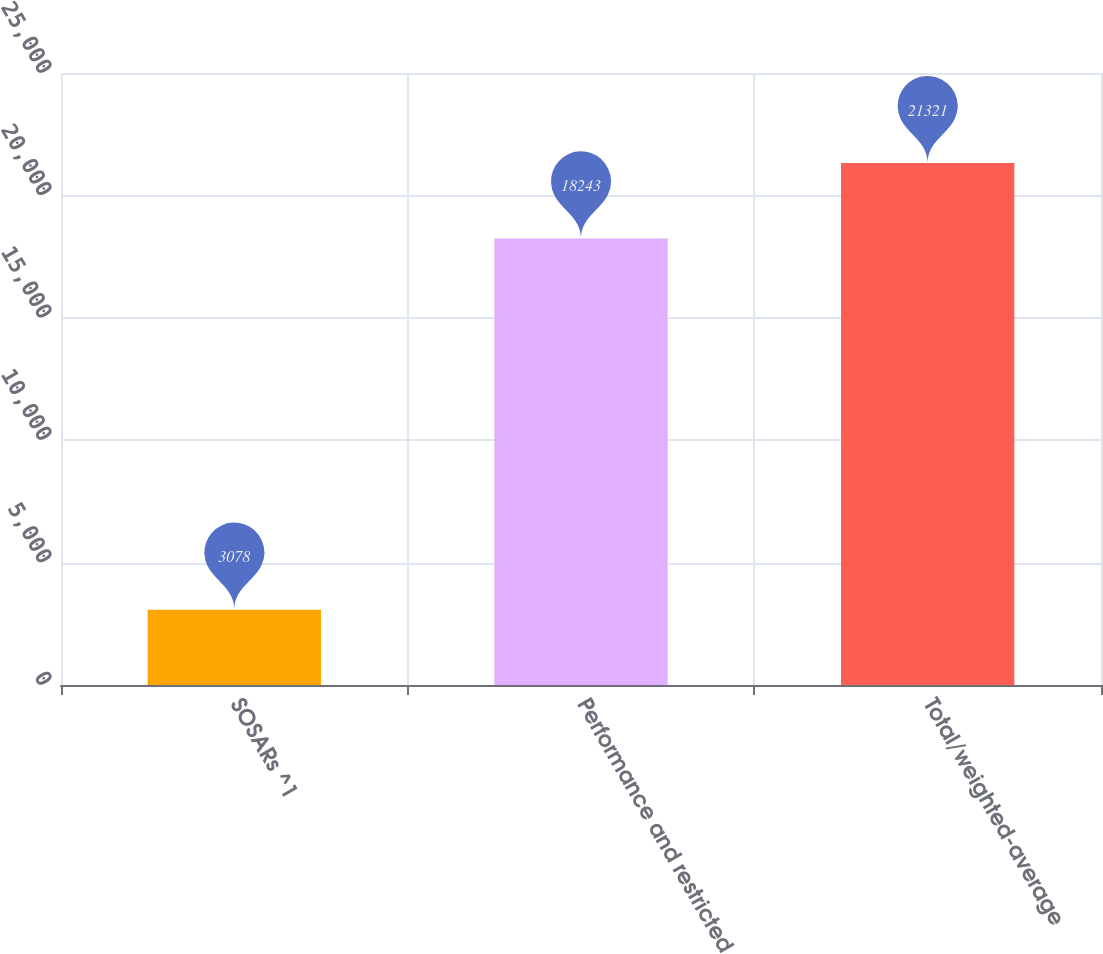<chart> <loc_0><loc_0><loc_500><loc_500><bar_chart><fcel>SOSARs ^1<fcel>Performance and restricted<fcel>Total/weighted-average<nl><fcel>3078<fcel>18243<fcel>21321<nl></chart> 